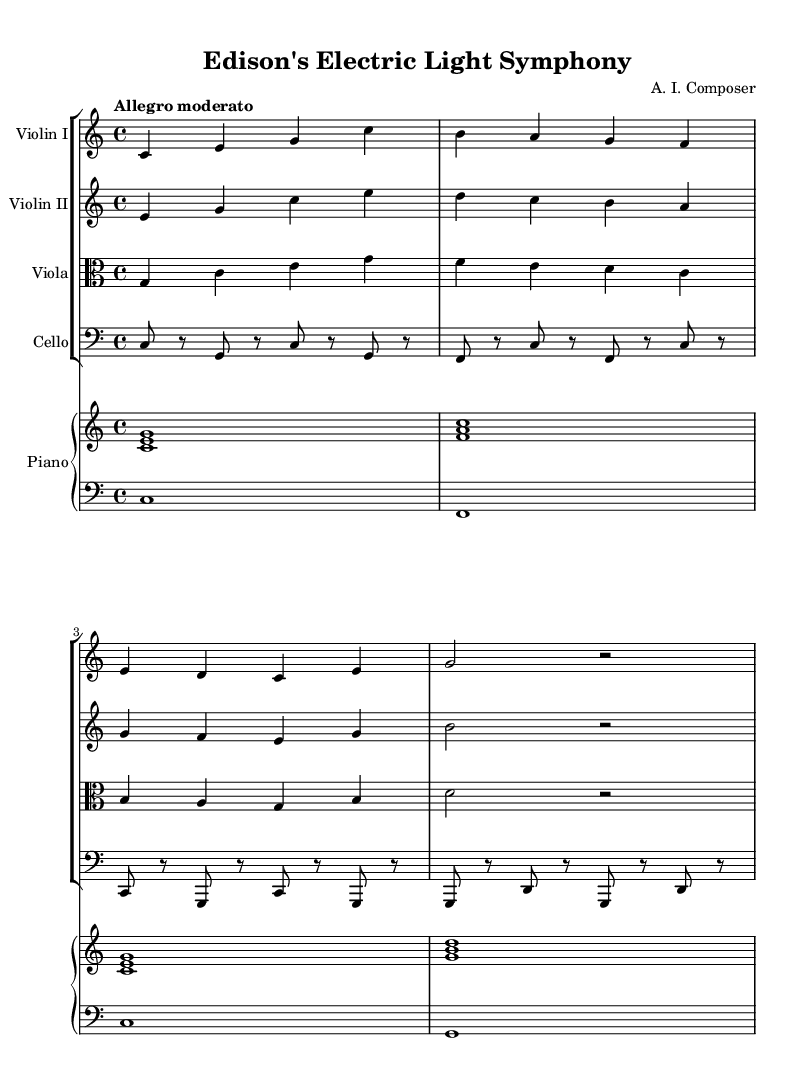What is the key signature of this music? The key signature is C major, which has no sharps or flats.
Answer: C major What is the time signature of this piece? The time signature is indicated as 4/4, meaning there are four beats in a measure and the quarter note gets one beat.
Answer: 4/4 What is the tempo marking for this music? The tempo marking says "Allegro moderato," which indicates a moderately fast tempo.
Answer: Allegro moderato How many instruments are in the score? The score consists of five distinct instrumental parts: two violins, one viola, one cello, and one piano (with two staves).
Answer: Five What is the first note played by violin I? Violin I starts with the note C in the fourth octave, which is the first note in its melody.
Answer: C Explain the relationship between the violin I and violin II parts in terms of harmony. In the harmony, both violin parts complement each other; Violin I plays a melodic line that is often accompanied by intervals from Violin II, creating a harmony that supports the overall texture of the piece, often focusing on C major chords.
Answer: They create harmony together What does the piano part provide in this composition? The piano part serves as both a harmonic foundation and a rhythmic element; the right hand plays chords while the left hand supports with bass notes, establishing the tonal center and offering fills between string sections.
Answer: Harmonic foundation and rhythm 